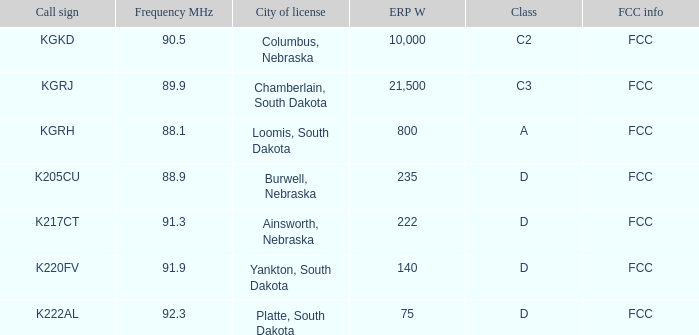What's the combined erp w value for the k222al call sign? 75.0. 